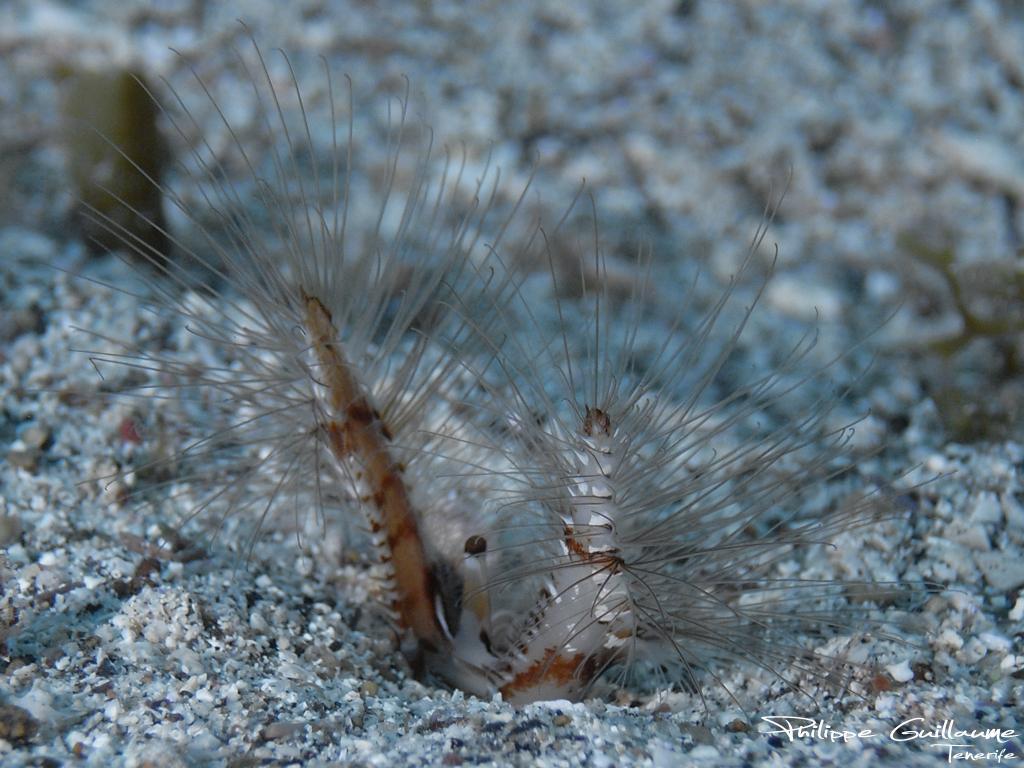Describe this image in one or two sentences. In this picture, we see an insect which looks like a caterpillar. At the bottom of the picture, we see small stones. In the background, it is white in color. This picture is blurred in the background. 